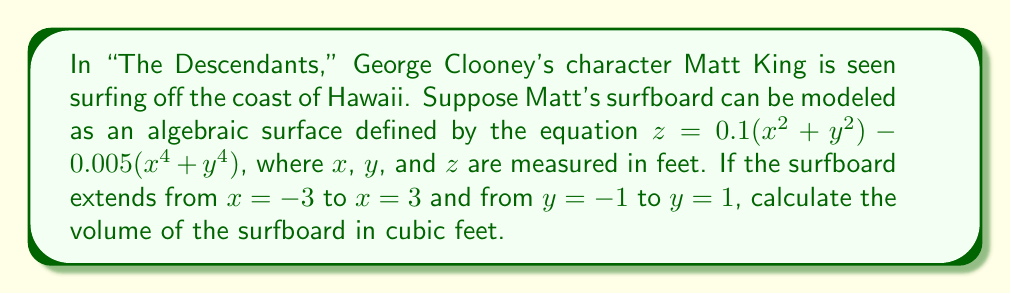Teach me how to tackle this problem. To calculate the volume of the surfboard, we need to integrate the given function over the specified region. Let's approach this step-by-step:

1) The volume of a solid bounded by a surface $z = f(x,y)$ over a region $R$ is given by the triple integral:

   $$V = \iint_R f(x,y) \, dA$$

2) In our case, $f(x,y) = 0.1(x^2 + y^2) - 0.005(x^4 + y^4)$, and the region $R$ is a rectangle with $-3 \leq x \leq 3$ and $-1 \leq y \leq 1$.

3) We can set up the double integral:

   $$V = \int_{-1}^1 \int_{-3}^3 [0.1(x^2 + y^2) - 0.005(x^4 + y^4)] \, dx \, dy$$

4) Let's integrate with respect to $x$ first:

   $$V = \int_{-1}^1 \left[0.1(x^3/3 + xy^2) - 0.005(x^5/5 + xy^4)\right]_{-3}^3 \, dy$$

5) Evaluating the inner integral:

   $$V = \int_{-1}^1 [0.1(9 + 3y^2) - 0.005(243/5 + 3y^4) + 0.1(9 + 3y^2) - 0.005(243/5 + 3y^4)] \, dy$$
   $$= \int_{-1}^1 [1.8 + 0.6y^2 - 0.486 - 0.015y^4] \, dy$$
   $$= \int_{-1}^1 [1.314 + 0.6y^2 - 0.015y^4] \, dy$$

6) Now integrate with respect to $y$:

   $$V = \left[1.314y + 0.2y^3 - 0.003y^5\right]_{-1}^1$$

7) Evaluate the limits:

   $$V = (1.314 + 0.2 - 0.003) - (-1.314 + 0.2 - 0.003)$$
   $$= 2.628$$

Therefore, the volume of the surfboard is approximately 2.628 cubic feet.
Answer: $2.628$ cubic feet 